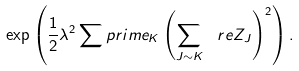Convert formula to latex. <formula><loc_0><loc_0><loc_500><loc_500>\exp \left ( \frac { 1 } { 2 } \lambda ^ { 2 } \sum p r i m e _ { K } \left ( \sum _ { J \sim K } \ r e Z _ { J } \right ) ^ { 2 } \right ) .</formula> 